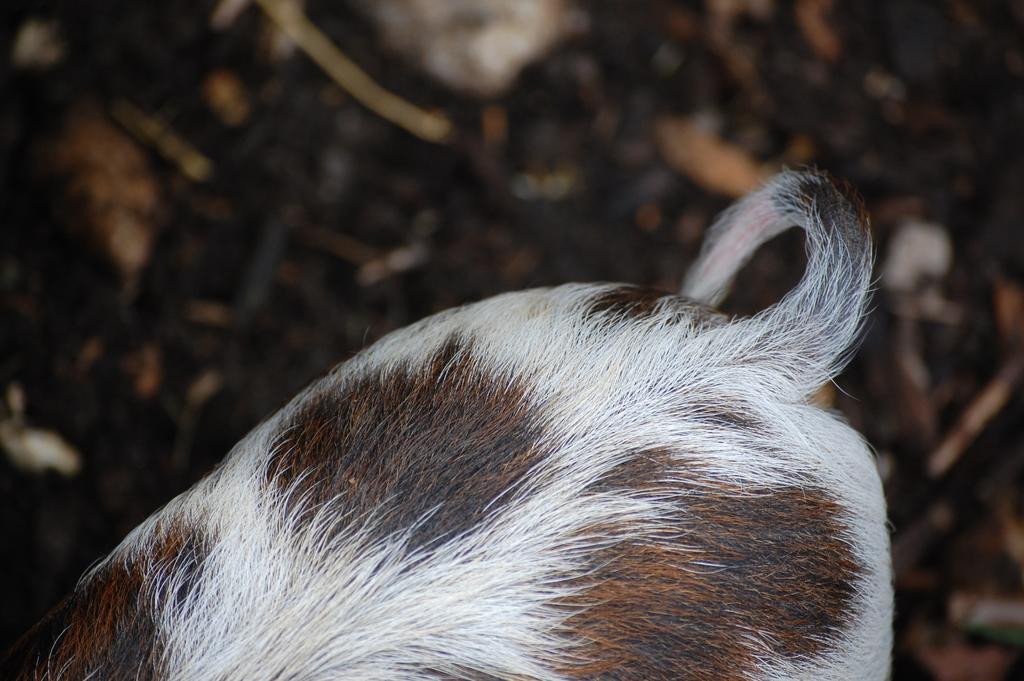Please provide a concise description of this image. In this image we can see the tail of an animal. 